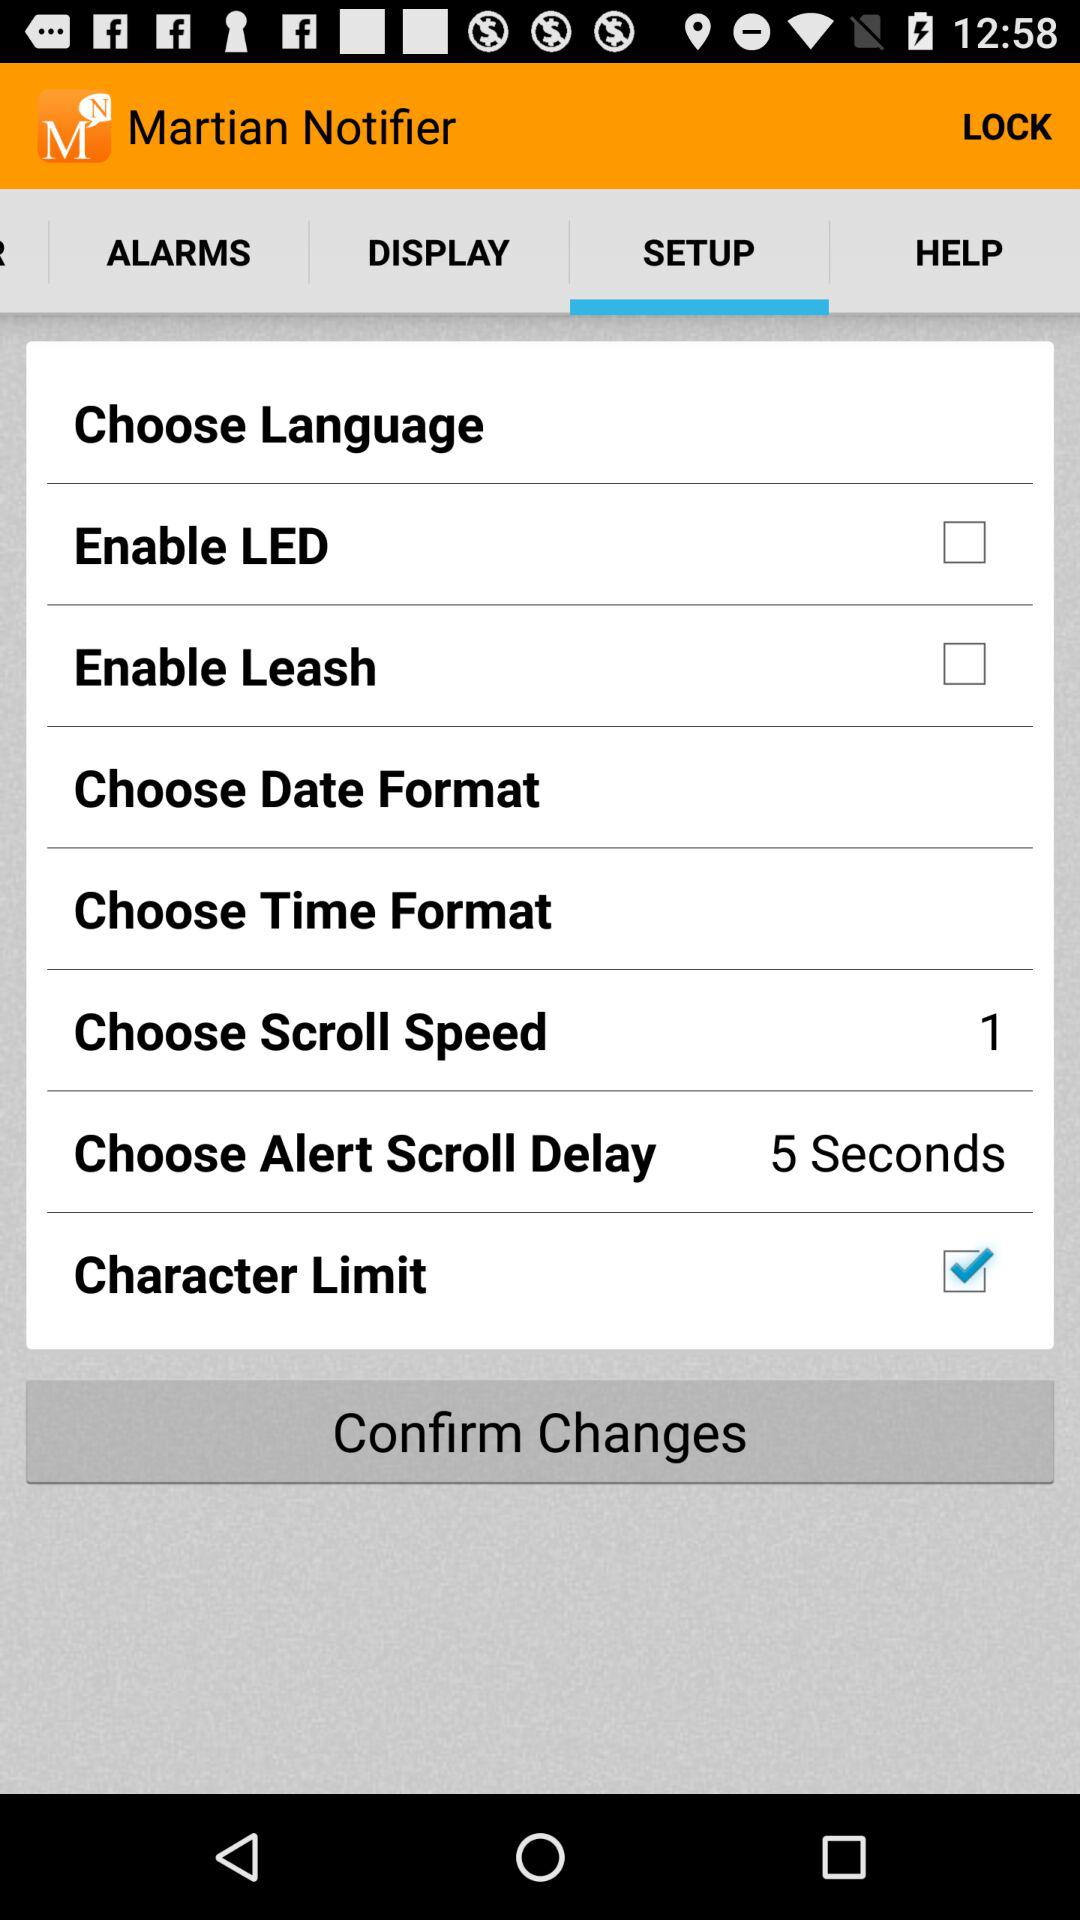Which tab has been selected? The selected tab is "SETUP". 